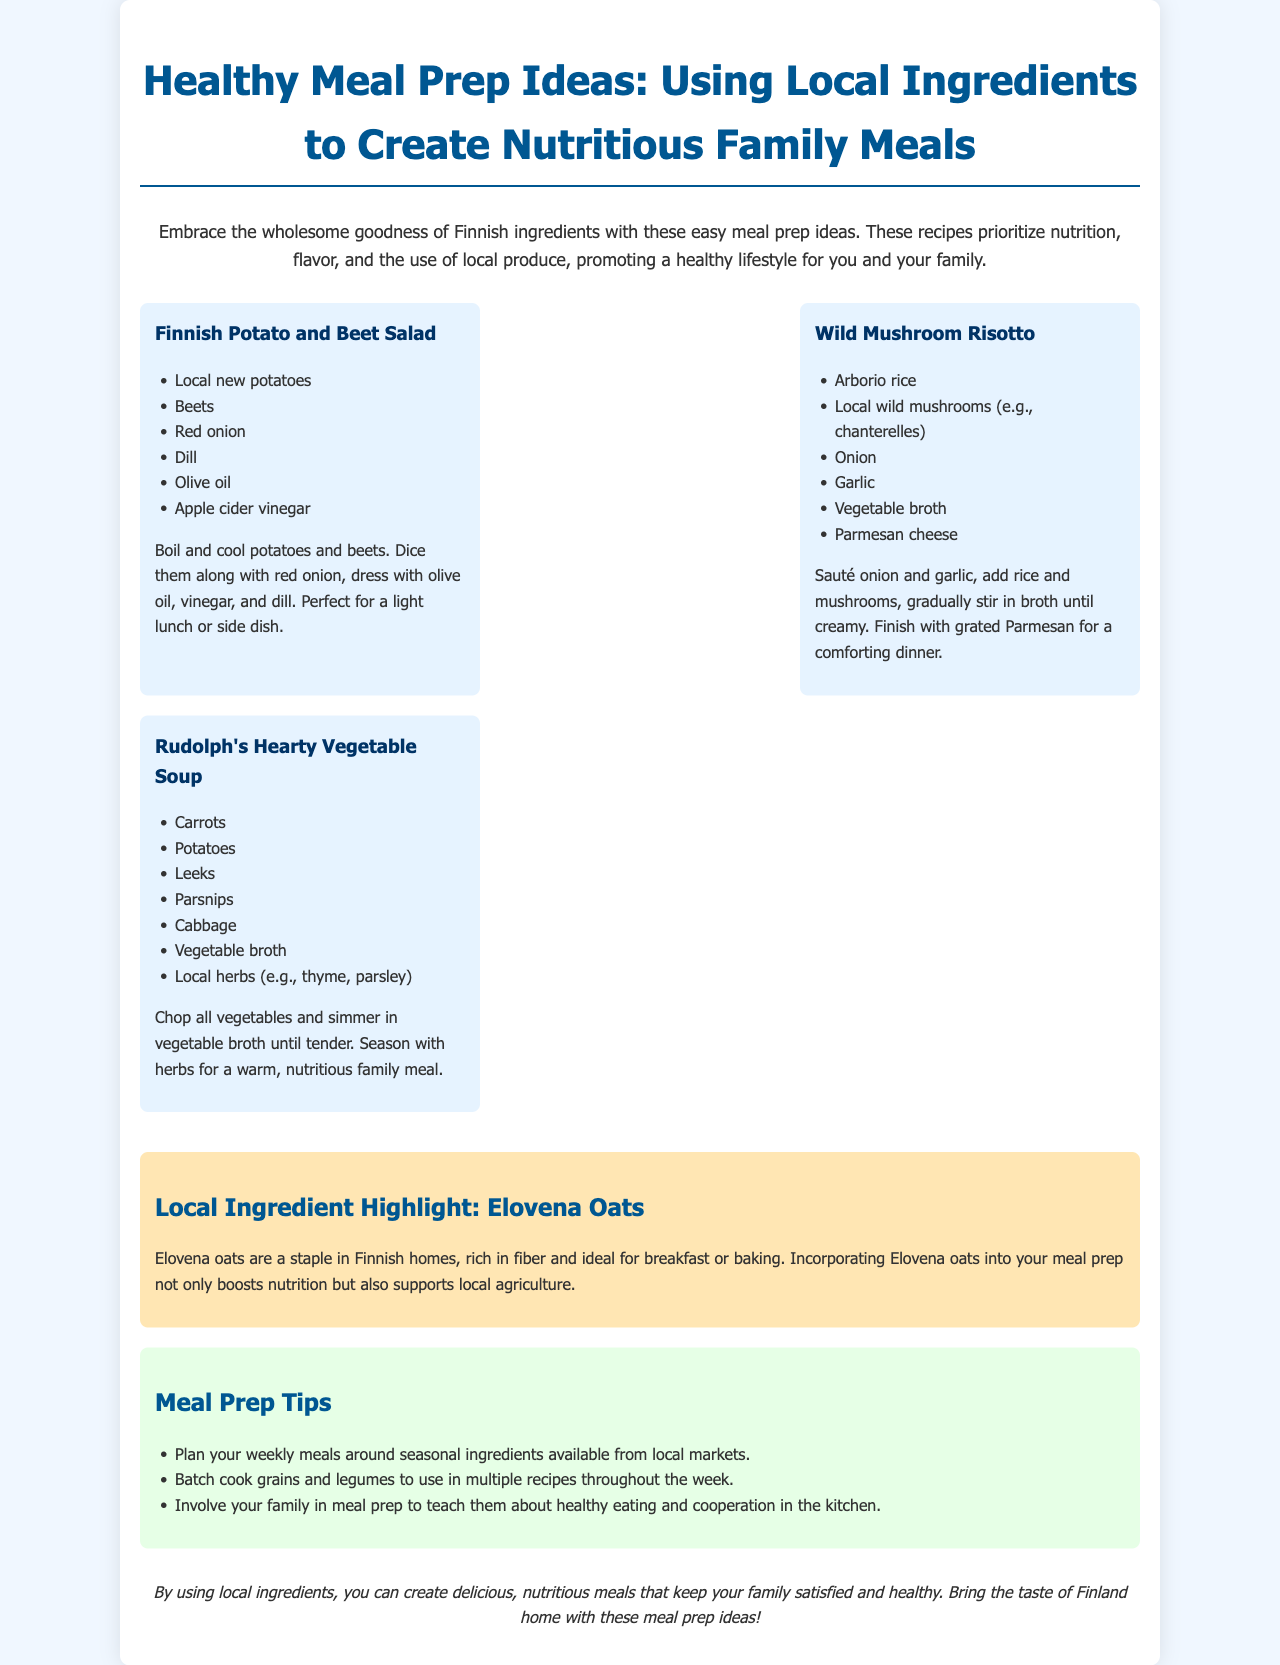What is the title of the brochure? The title of the brochure is prominently displayed at the top and introduces the topic of meal prep ideas.
Answer: Healthy Meal Prep Ideas: Using Local Ingredients How many recipes are included in the document? The document lists three specific recipes under the meal prep section.
Answer: Three What ingredient is highlighted in the document? The highlighted local ingredient is mentioned within a dedicated section of the brochure.
Answer: Elovena oats What type of cheese is used in the Wild Mushroom Risotto? The recipe specifies the type of cheese added to this dish for flavor.
Answer: Parmesan cheese What is a suggested action for family involvement in meal prep? The tips section provides a suggestion on how to involve family members in the cooking process.
Answer: Involve your family What is a main ingredient in Rudolph's Hearty Vegetable Soup? The soup recipe is listed with several key ingredients, one of which serves as a primary component.
Answer: Carrots What is the nutrition focus in the brochure? The brochure emphasizes the aspect of nutrition throughout the meal prep ideas.
Answer: Nutrition What cooking method is used for the Finnish Potato and Beet Salad? The preparation method for the salad is briefly outlined in the recipe description.
Answer: Boil 